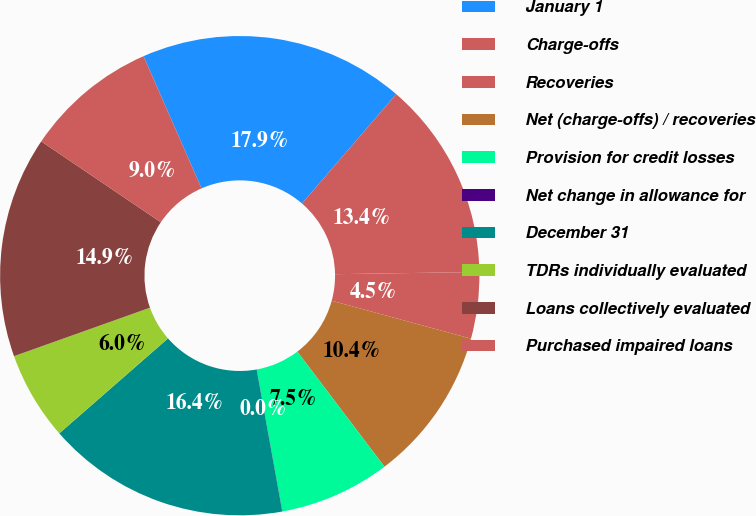Convert chart. <chart><loc_0><loc_0><loc_500><loc_500><pie_chart><fcel>January 1<fcel>Charge-offs<fcel>Recoveries<fcel>Net (charge-offs) / recoveries<fcel>Provision for credit losses<fcel>Net change in allowance for<fcel>December 31<fcel>TDRs individually evaluated<fcel>Loans collectively evaluated<fcel>Purchased impaired loans<nl><fcel>17.9%<fcel>13.43%<fcel>4.48%<fcel>10.45%<fcel>7.47%<fcel>0.01%<fcel>16.41%<fcel>5.98%<fcel>14.92%<fcel>8.96%<nl></chart> 